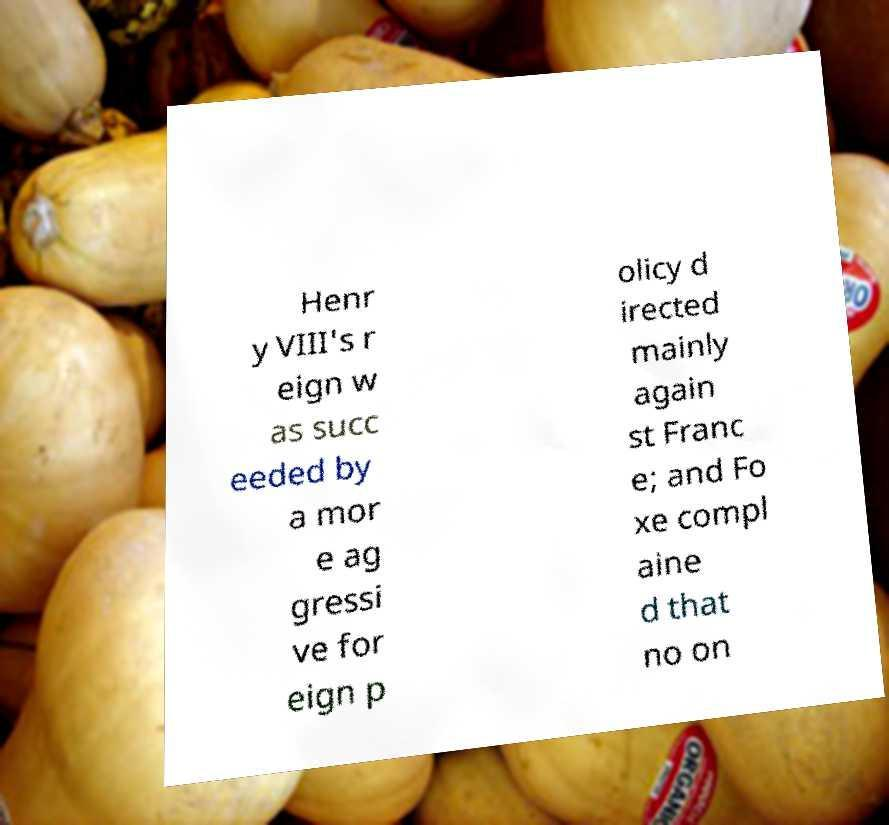There's text embedded in this image that I need extracted. Can you transcribe it verbatim? Henr y VIII's r eign w as succ eeded by a mor e ag gressi ve for eign p olicy d irected mainly again st Franc e; and Fo xe compl aine d that no on 